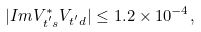Convert formula to latex. <formula><loc_0><loc_0><loc_500><loc_500>| I m V ^ { * } _ { t ^ { ^ { \prime } } s } V _ { t ^ { ^ { \prime } } d } | \leq 1 . 2 \times 1 0 ^ { - 4 } ,</formula> 